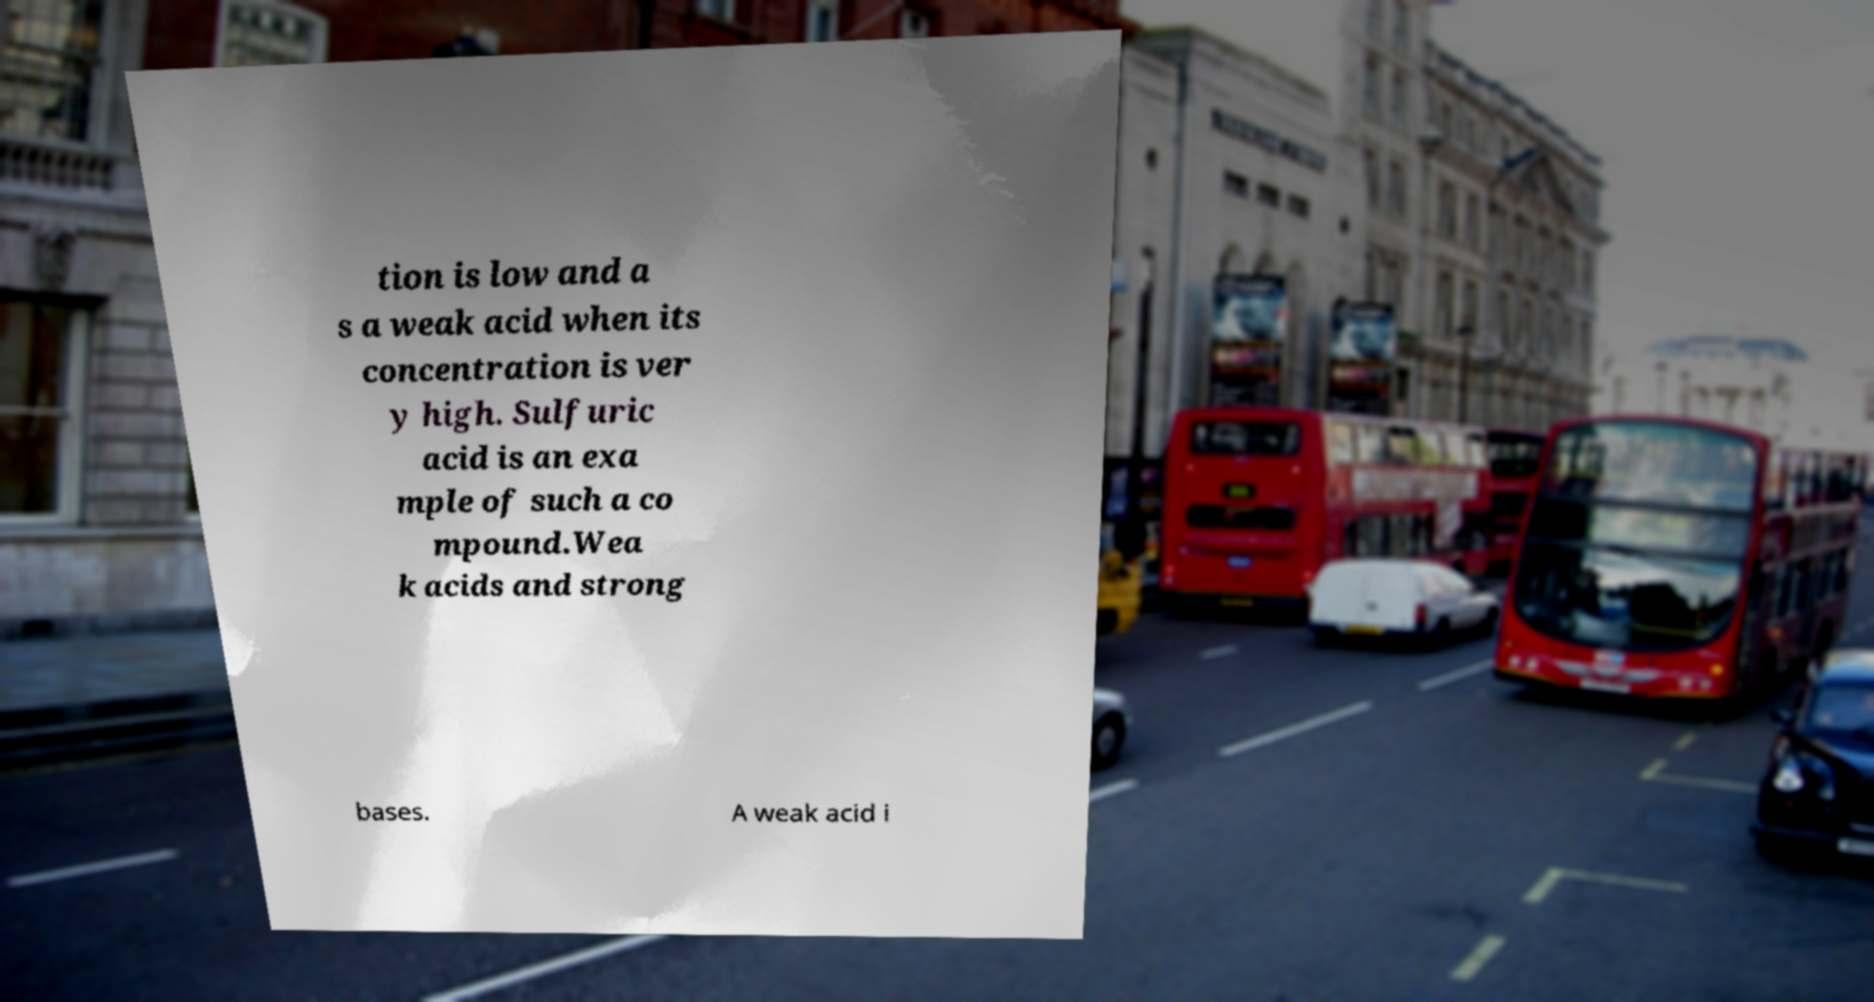Could you extract and type out the text from this image? tion is low and a s a weak acid when its concentration is ver y high. Sulfuric acid is an exa mple of such a co mpound.Wea k acids and strong bases. A weak acid i 